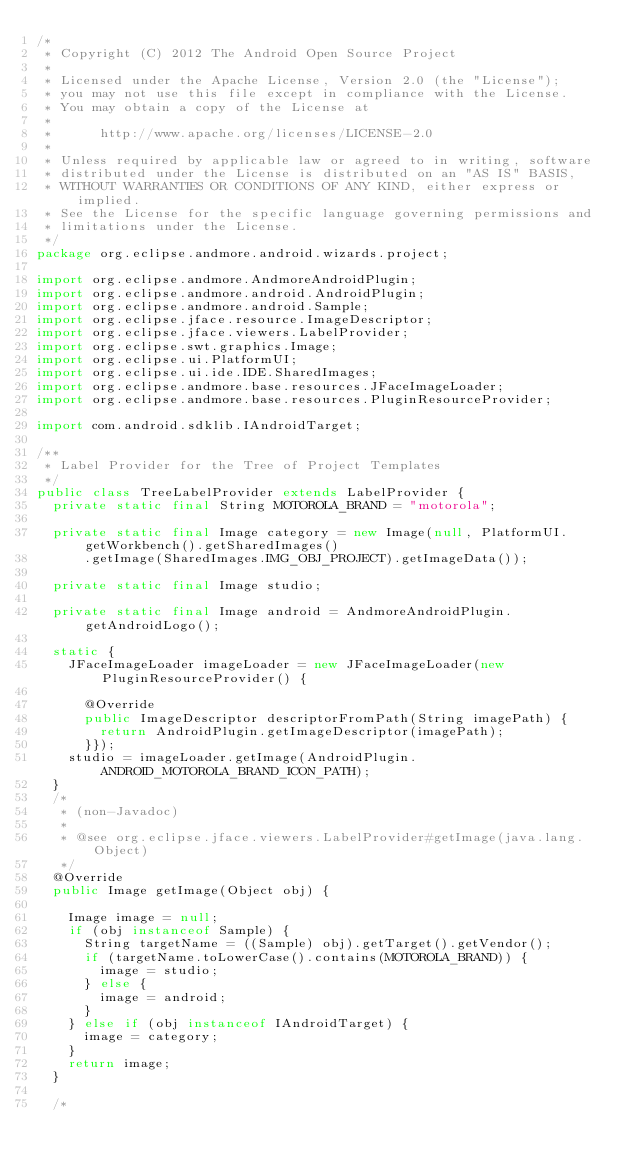<code> <loc_0><loc_0><loc_500><loc_500><_Java_>/*
 * Copyright (C) 2012 The Android Open Source Project
 *
 * Licensed under the Apache License, Version 2.0 (the "License");
 * you may not use this file except in compliance with the License.
 * You may obtain a copy of the License at
 *
 *      http://www.apache.org/licenses/LICENSE-2.0
 *
 * Unless required by applicable law or agreed to in writing, software
 * distributed under the License is distributed on an "AS IS" BASIS,
 * WITHOUT WARRANTIES OR CONDITIONS OF ANY KIND, either express or implied.
 * See the License for the specific language governing permissions and
 * limitations under the License.
 */
package org.eclipse.andmore.android.wizards.project;

import org.eclipse.andmore.AndmoreAndroidPlugin;
import org.eclipse.andmore.android.AndroidPlugin;
import org.eclipse.andmore.android.Sample;
import org.eclipse.jface.resource.ImageDescriptor;
import org.eclipse.jface.viewers.LabelProvider;
import org.eclipse.swt.graphics.Image;
import org.eclipse.ui.PlatformUI;
import org.eclipse.ui.ide.IDE.SharedImages;
import org.eclipse.andmore.base.resources.JFaceImageLoader;
import org.eclipse.andmore.base.resources.PluginResourceProvider;

import com.android.sdklib.IAndroidTarget;

/**
 * Label Provider for the Tree of Project Templates
 */
public class TreeLabelProvider extends LabelProvider {
	private static final String MOTOROLA_BRAND = "motorola";

	private static final Image category = new Image(null, PlatformUI.getWorkbench().getSharedImages()
			.getImage(SharedImages.IMG_OBJ_PROJECT).getImageData());

	private static final Image studio;

	private static final Image android = AndmoreAndroidPlugin.getAndroidLogo();

	static {
		JFaceImageLoader imageLoader = new JFaceImageLoader(new PluginResourceProvider() {

			@Override
			public ImageDescriptor descriptorFromPath(String imagePath) {
				return AndroidPlugin.getImageDescriptor(imagePath);
			}});
		studio = imageLoader.getImage(AndroidPlugin.ANDROID_MOTOROLA_BRAND_ICON_PATH);
	}
	/*
	 * (non-Javadoc)
	 * 
	 * @see org.eclipse.jface.viewers.LabelProvider#getImage(java.lang.Object)
	 */
	@Override
	public Image getImage(Object obj) {

		Image image = null;
		if (obj instanceof Sample) {
			String targetName = ((Sample) obj).getTarget().getVendor();
			if (targetName.toLowerCase().contains(MOTOROLA_BRAND)) {
				image = studio;
			} else {
				image = android;
			}
		} else if (obj instanceof IAndroidTarget) {
			image = category;
		}
		return image;
	}

	/*</code> 